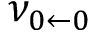Convert formula to latex. <formula><loc_0><loc_0><loc_500><loc_500>\nu _ { 0 \leftarrow 0 }</formula> 